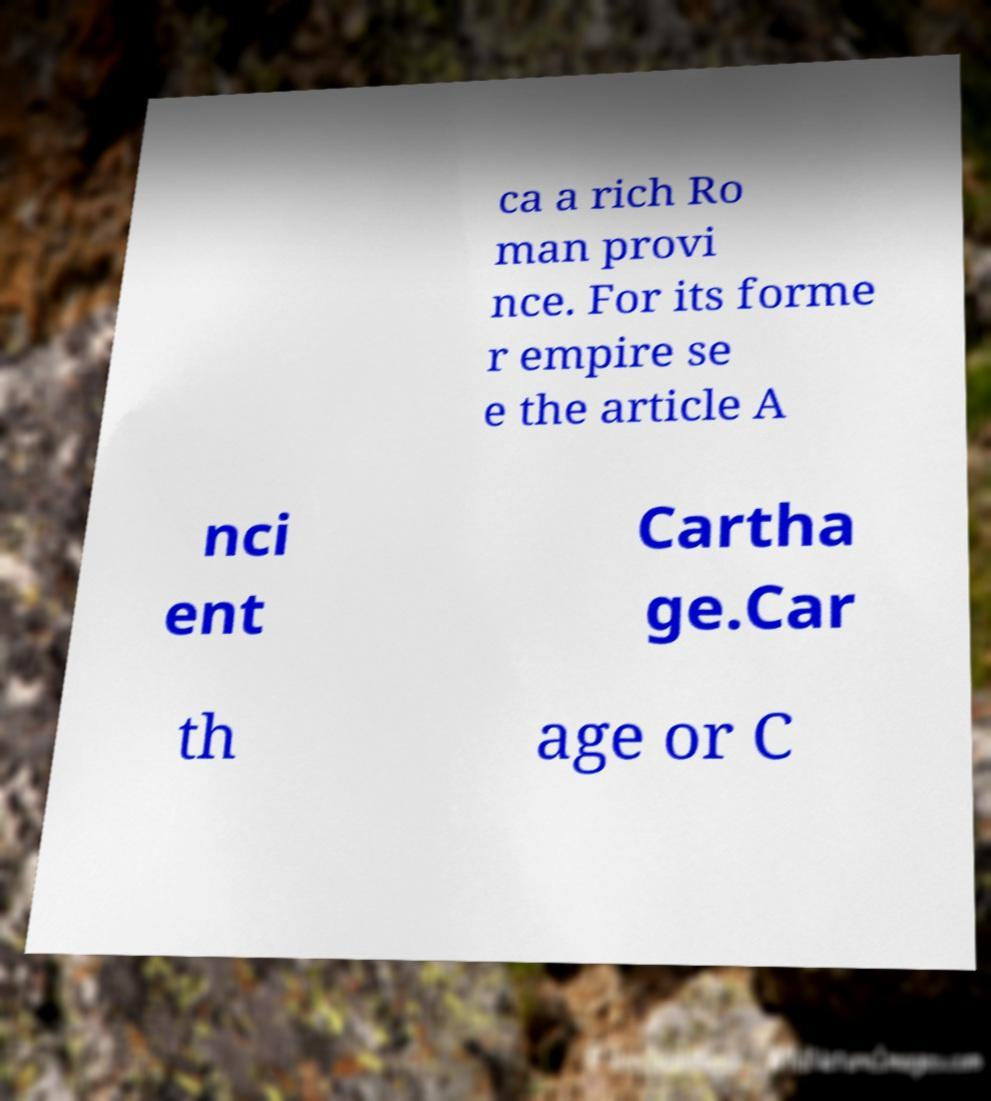I need the written content from this picture converted into text. Can you do that? ca a rich Ro man provi nce. For its forme r empire se e the article A nci ent Cartha ge.Car th age or C 